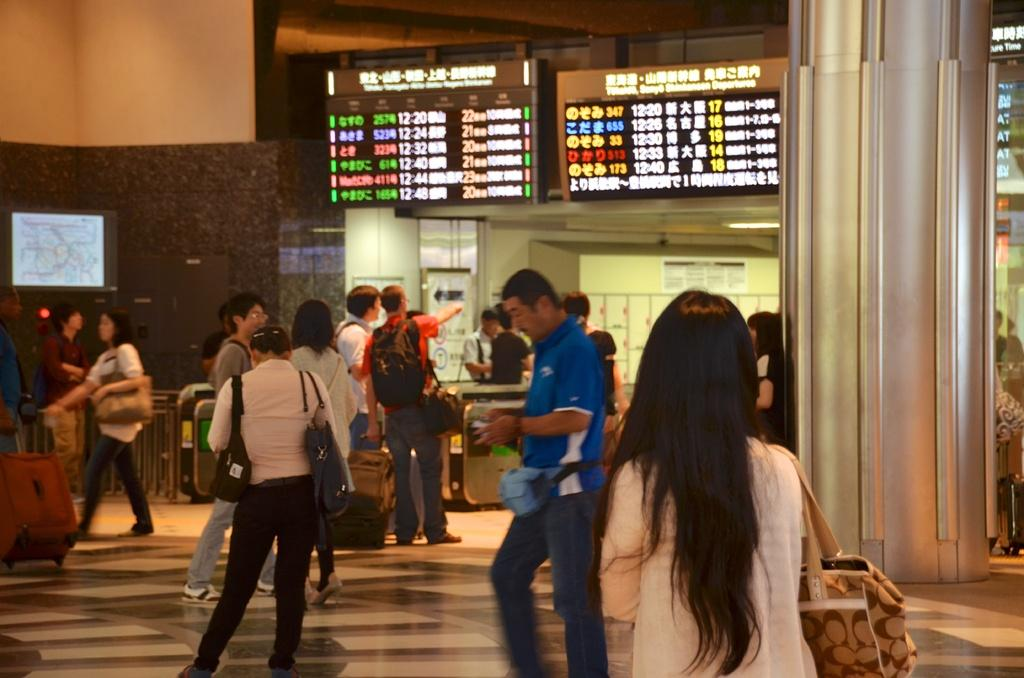How many people are in the group shown in the image? There is a group of people in the image, but the exact number is not specified. What are some people in the group wearing? Some people in the group are wearing bags. What are some people in the group holding? Some people in the group are holding something, but the specific objects are not mentioned. What type of structures can be seen in the background of the image? There are screens, fencing, a pillar, and a wall visible in the image. How much wealth is stored in the jar on the pillar in the image? There is no jar or pillar present in the image, so it is not possible to determine the amount of wealth stored in a jar on a pillar. 